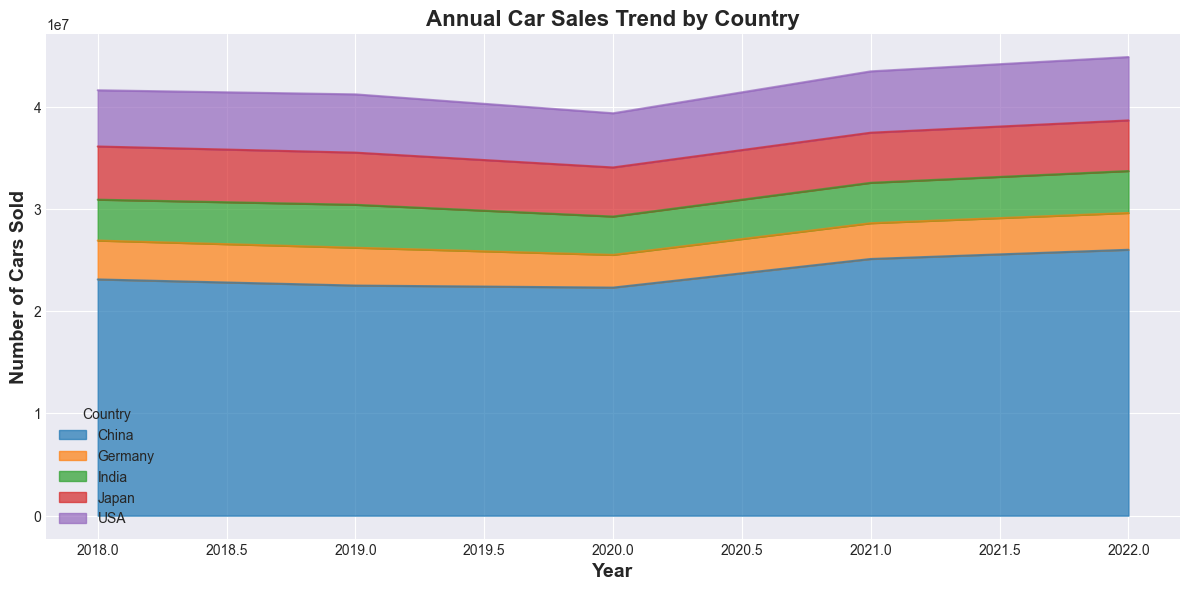Which country had the highest car sales in 2022? In the figure, look at the height/area of the sections at the year 2022. The section for China is the largest.
Answer: China How did car sales in India change from 2019 to 2020? In the figure, compare the height/area of the section for India between 2019 and 2020. The area decreased from 2019 to 2020, showing a reduction in sales.
Answer: Decreased Which country shows the most consistent car sales pattern over the years? Examine the stability of the areas of each section over the years in the figure. Japan's section exhibits minimal fluctuations compared to other countries.
Answer: Japan What is the difference in car sales between the USA and Germany in 2022? In the figure, identify the heights of USA and Germany for the year 2022. Subtract the value for Germany from the value for the USA (6200000 - 3600000).
Answer: 2600000 Which two countries had overlapping car sales values at any point during the given years? Check the overlapping sections in the figure. India and Germany show some overlap around the years 2018 and 2019.
Answer: India and Germany What trend is observed for China's car sales from 2018 to 2022? In the figure, follow the section for China over the years 2018 to 2022. The area starts at a high value, slightly dips, and then increases significantly.
Answer: Increasing trend Which year showed the highest total car sales across all countries? Sum the heights/areas of all sections for each year and identify the highest. The total area appears highest in 2022.
Answer: 2022 How did car sales in Japan change from 2020 to 2021? In the figure, compare the height/area of the section for Japan between 2020 and 2021. It slightly increased.
Answer: Increased Which country had the largest increase in car sales from 2020 to 2021? In the figure, compare the increases in area height for each country between 2020 and 2021. China shows the largest increase.
Answer: China How did the total car sales in 2021 compare to those in 2020? Sum the heights/areas of all sections for 2020 and 2021. There is an increase in the total area from 2020 to 2021, indicating an overall increase in sales.
Answer: Increased 